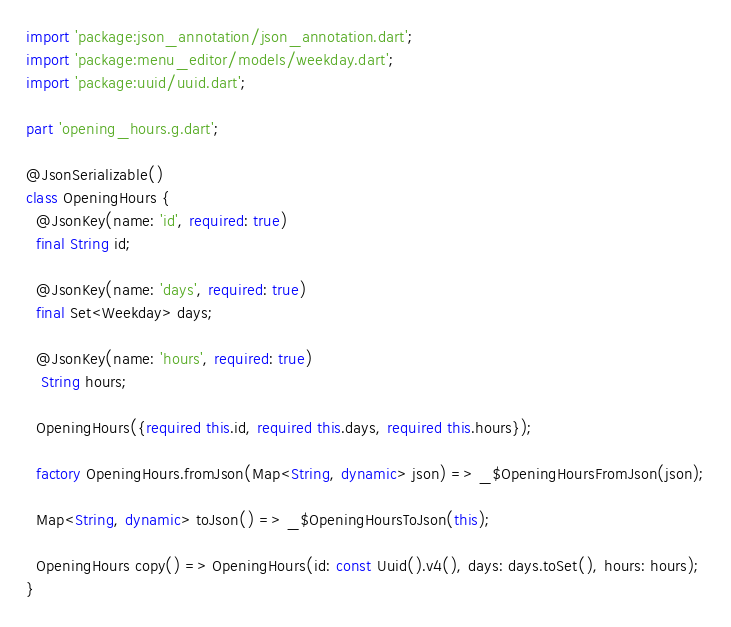<code> <loc_0><loc_0><loc_500><loc_500><_Dart_>import 'package:json_annotation/json_annotation.dart';
import 'package:menu_editor/models/weekday.dart';
import 'package:uuid/uuid.dart';

part 'opening_hours.g.dart';

@JsonSerializable()
class OpeningHours {
  @JsonKey(name: 'id', required: true)
  final String id;

  @JsonKey(name: 'days', required: true)
  final Set<Weekday> days;

  @JsonKey(name: 'hours', required: true)
   String hours;

  OpeningHours({required this.id, required this.days, required this.hours});

  factory OpeningHours.fromJson(Map<String, dynamic> json) => _$OpeningHoursFromJson(json);

  Map<String, dynamic> toJson() => _$OpeningHoursToJson(this);

  OpeningHours copy() => OpeningHours(id: const Uuid().v4(), days: days.toSet(), hours: hours);
}
</code> 